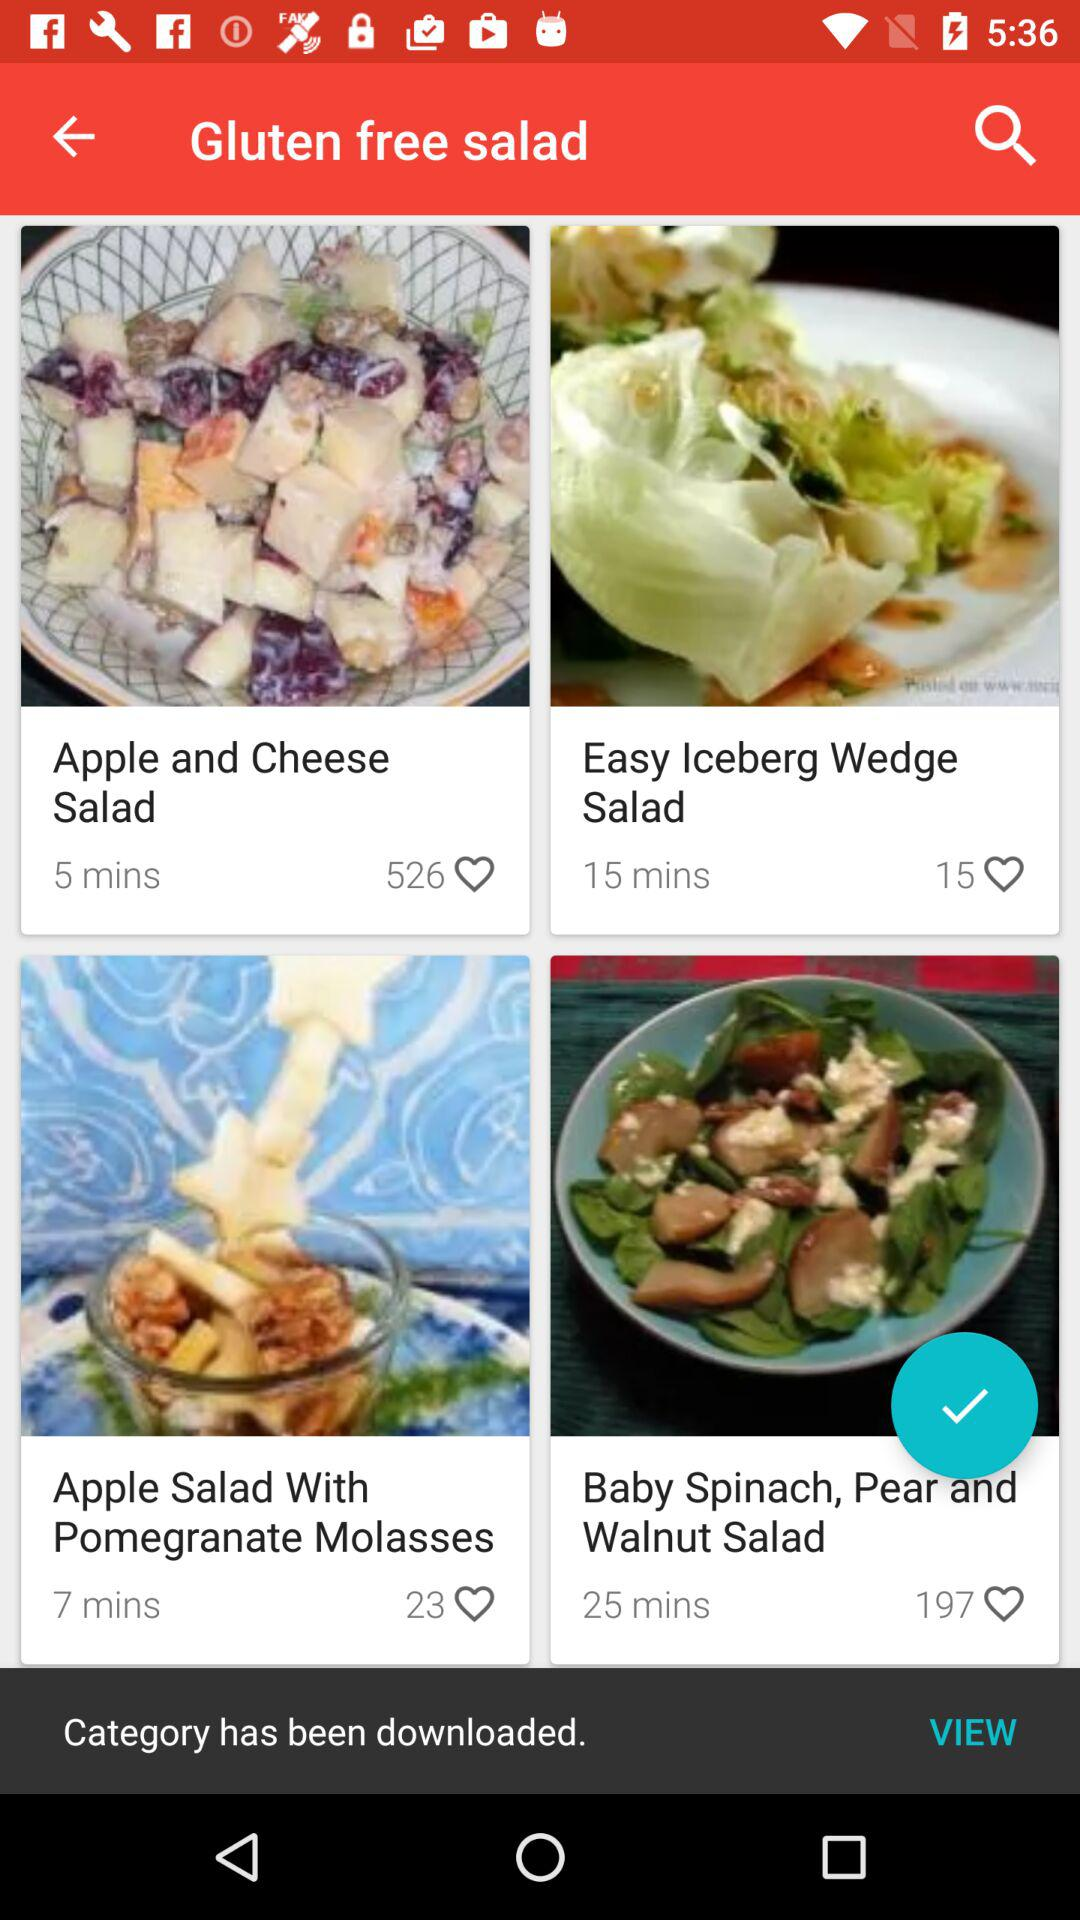What are the different available gluten free salads? The different available gluten free salads are "Apple and Cheese Salad", "Easy Iceberg Wedge Salad", "Apple Salad With Pomegranate Molasses" and "Baby Spinach, Pear and Walnut Salad". 